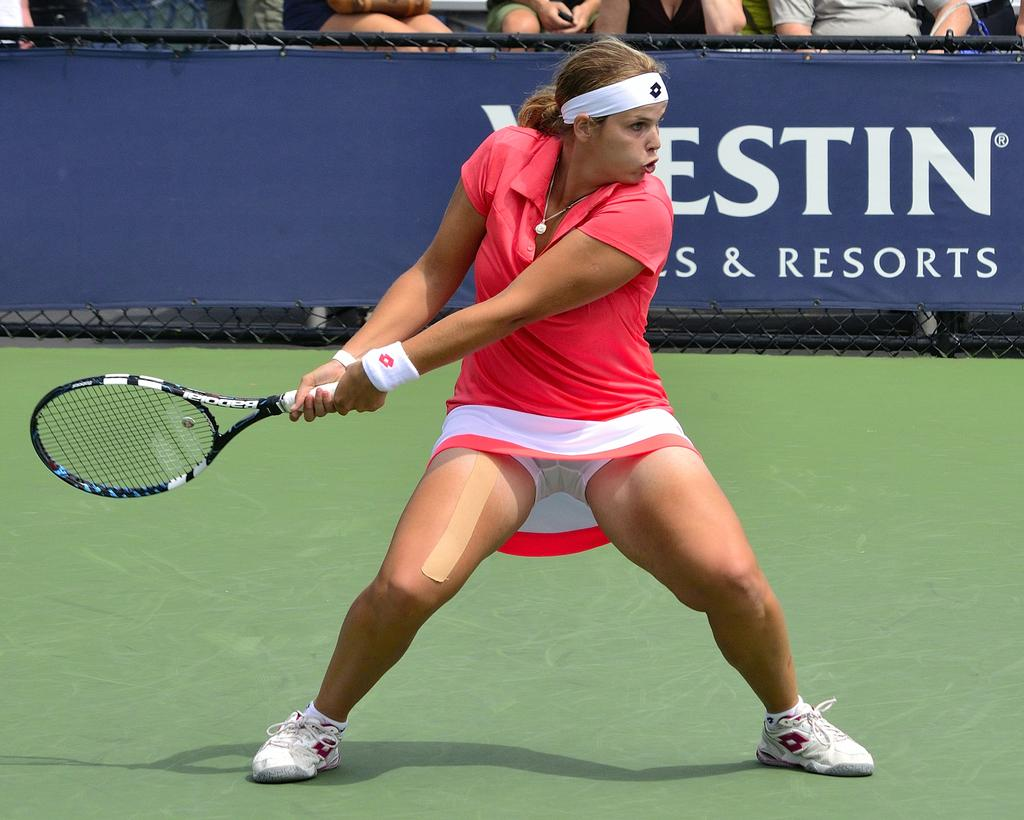Who is the main subject in the image? There is a woman in the image. What is the woman doing in the image? The woman is standing on the ground and holding a racket. Are there any other people in the image? Yes, there are people sitting in the image. What type of representative is the woman in the image? There is no indication in the image that the woman is a representative of any organization or group. 